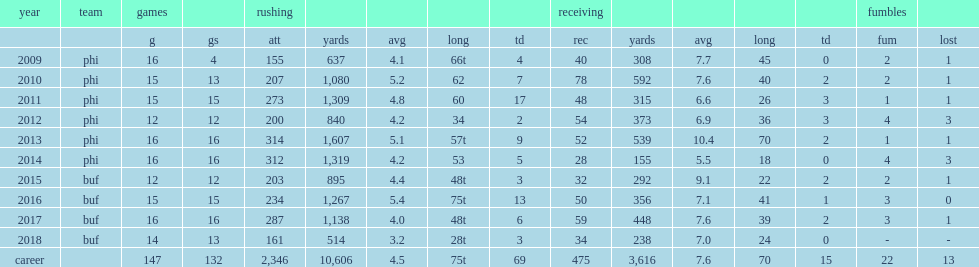Could you parse the entire table? {'header': ['year', 'team', 'games', '', 'rushing', '', '', '', '', 'receiving', '', '', '', '', 'fumbles', ''], 'rows': [['', '', 'g', 'gs', 'att', 'yards', 'avg', 'long', 'td', 'rec', 'yards', 'avg', 'long', 'td', 'fum', 'lost'], ['2009', 'phi', '16', '4', '155', '637', '4.1', '66t', '4', '40', '308', '7.7', '45', '0', '2', '1'], ['2010', 'phi', '15', '13', '207', '1,080', '5.2', '62', '7', '78', '592', '7.6', '40', '2', '2', '1'], ['2011', 'phi', '15', '15', '273', '1,309', '4.8', '60', '17', '48', '315', '6.6', '26', '3', '1', '1'], ['2012', 'phi', '12', '12', '200', '840', '4.2', '34', '2', '54', '373', '6.9', '36', '3', '4', '3'], ['2013', 'phi', '16', '16', '314', '1,607', '5.1', '57t', '9', '52', '539', '10.4', '70', '2', '1', '1'], ['2014', 'phi', '16', '16', '312', '1,319', '4.2', '53', '5', '28', '155', '5.5', '18', '0', '4', '3'], ['2015', 'buf', '12', '12', '203', '895', '4.4', '48t', '3', '32', '292', '9.1', '22', '2', '2', '1'], ['2016', 'buf', '15', '15', '234', '1,267', '5.4', '75t', '13', '50', '356', '7.1', '41', '1', '3', '0'], ['2017', 'buf', '16', '16', '287', '1,138', '4.0', '48t', '6', '59', '448', '7.6', '39', '2', '3', '1'], ['2018', 'buf', '14', '13', '161', '514', '3.2', '28t', '3', '34', '238', '7.0', '24', '0', '-', '-'], ['career', '', '147', '132', '2,346', '10,606', '4.5', '75t', '69', '475', '3,616', '7.6', '70', '15', '22', '13']]} How many rushing yards did mccoy finish the 2018 season with? 514.0. How many touchdowns did mccoy finish the 2018 season with? 3.0. 